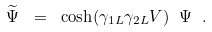Convert formula to latex. <formula><loc_0><loc_0><loc_500><loc_500>\widetilde { \Psi } \ = \ \cosh ( \gamma _ { 1 L } \gamma _ { 2 L } V ) \ \Psi \ .</formula> 